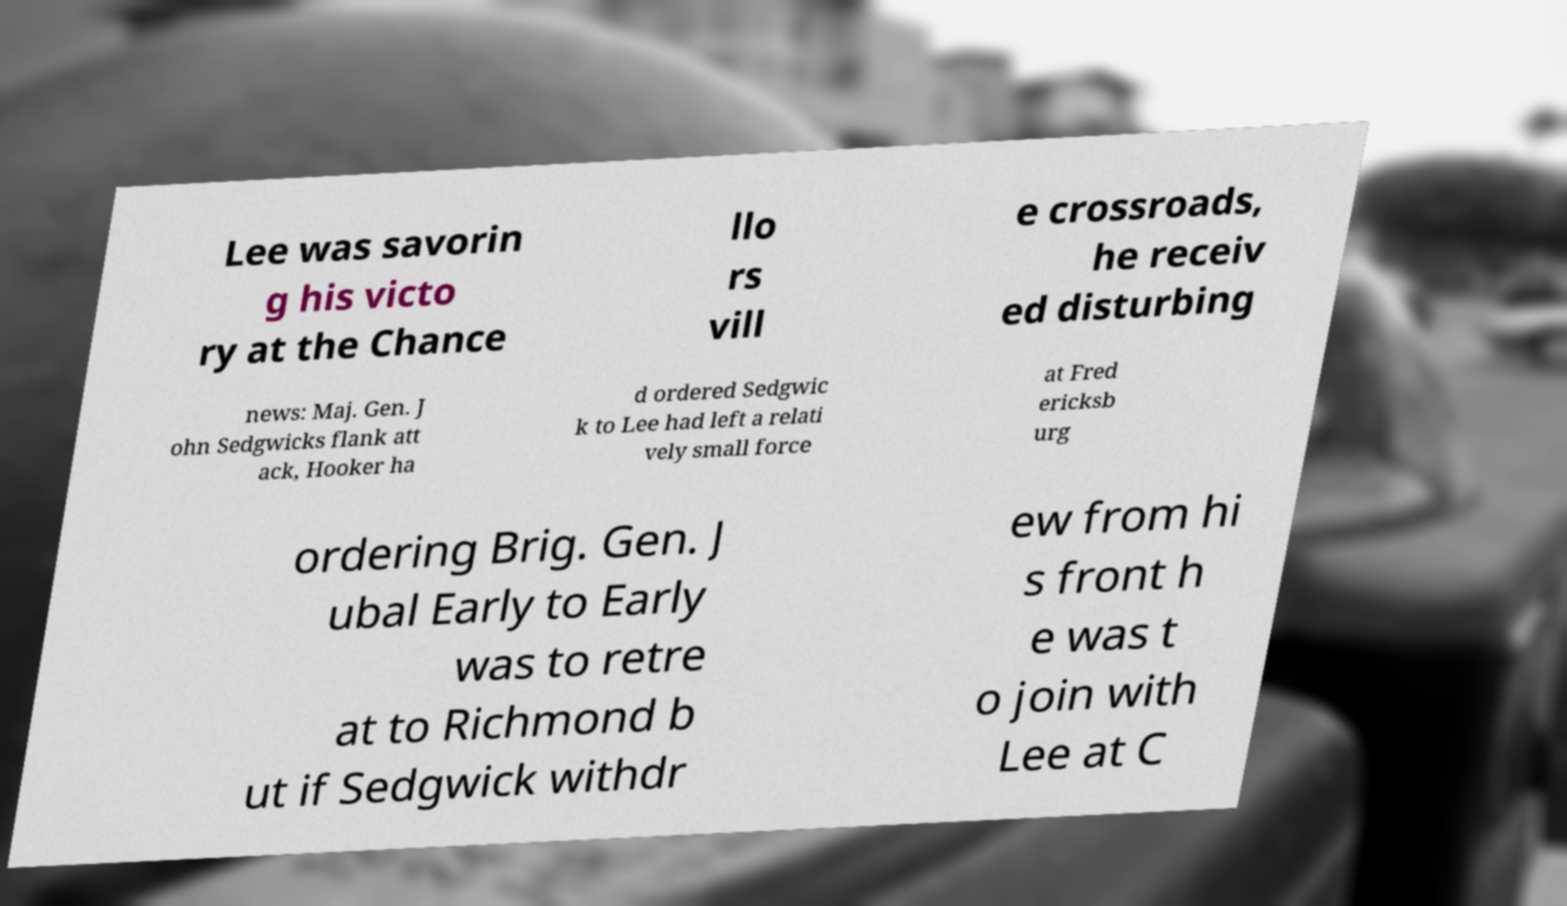Please identify and transcribe the text found in this image. Lee was savorin g his victo ry at the Chance llo rs vill e crossroads, he receiv ed disturbing news: Maj. Gen. J ohn Sedgwicks flank att ack, Hooker ha d ordered Sedgwic k to Lee had left a relati vely small force at Fred ericksb urg ordering Brig. Gen. J ubal Early to Early was to retre at to Richmond b ut if Sedgwick withdr ew from hi s front h e was t o join with Lee at C 